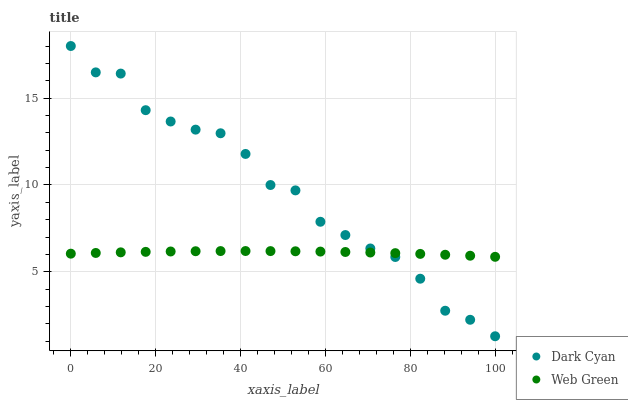Does Web Green have the minimum area under the curve?
Answer yes or no. Yes. Does Dark Cyan have the maximum area under the curve?
Answer yes or no. Yes. Does Web Green have the maximum area under the curve?
Answer yes or no. No. Is Web Green the smoothest?
Answer yes or no. Yes. Is Dark Cyan the roughest?
Answer yes or no. Yes. Is Web Green the roughest?
Answer yes or no. No. Does Dark Cyan have the lowest value?
Answer yes or no. Yes. Does Web Green have the lowest value?
Answer yes or no. No. Does Dark Cyan have the highest value?
Answer yes or no. Yes. Does Web Green have the highest value?
Answer yes or no. No. Does Web Green intersect Dark Cyan?
Answer yes or no. Yes. Is Web Green less than Dark Cyan?
Answer yes or no. No. Is Web Green greater than Dark Cyan?
Answer yes or no. No. 